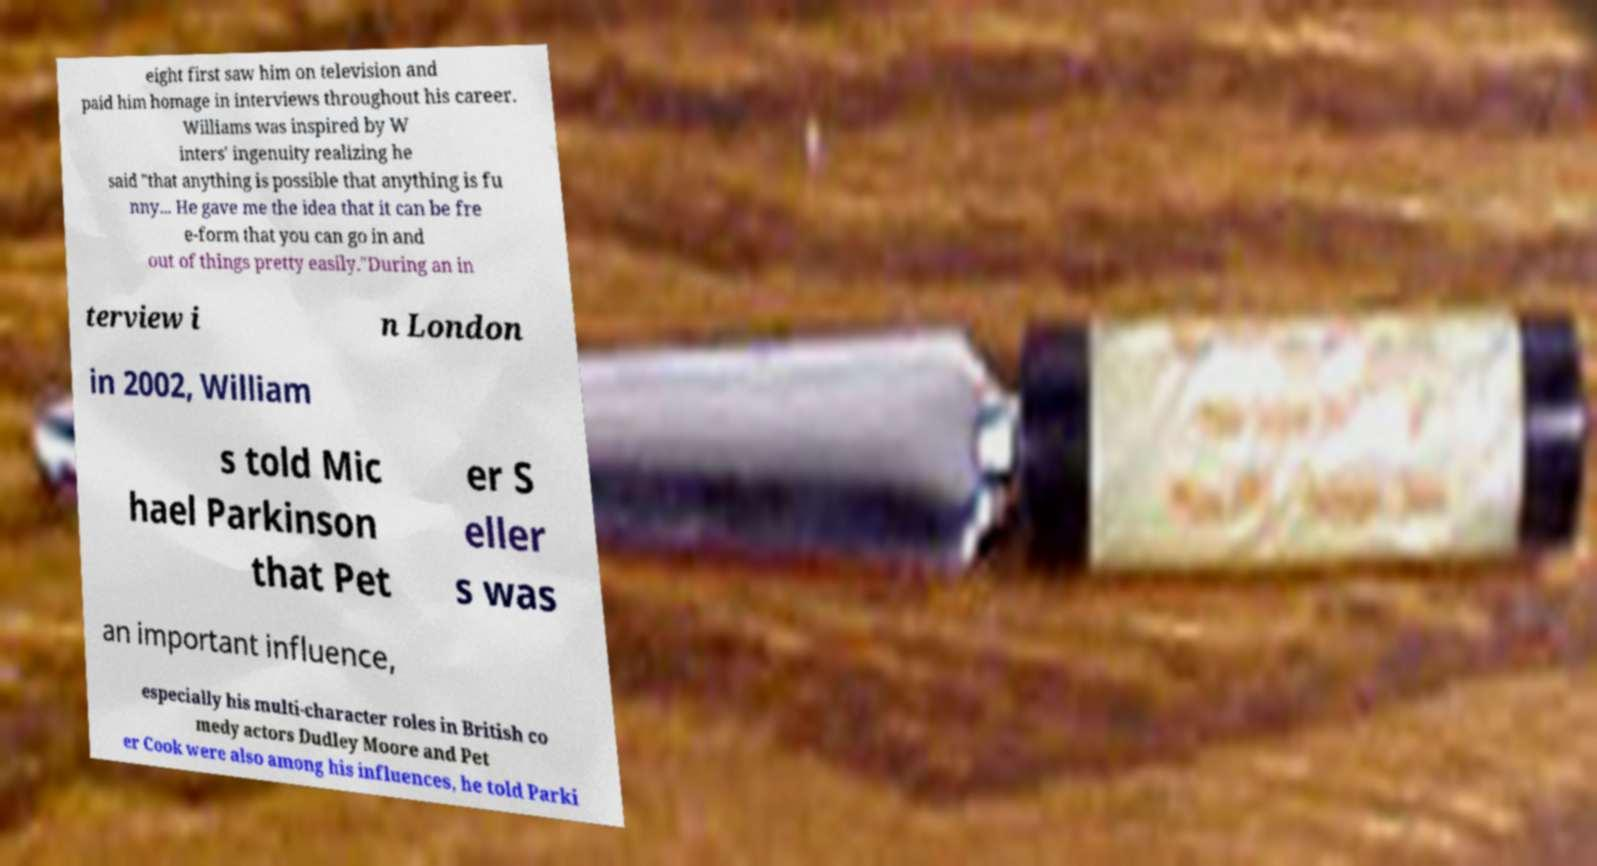Could you assist in decoding the text presented in this image and type it out clearly? eight first saw him on television and paid him homage in interviews throughout his career. Williams was inspired by W inters' ingenuity realizing he said "that anything is possible that anything is fu nny... He gave me the idea that it can be fre e-form that you can go in and out of things pretty easily."During an in terview i n London in 2002, William s told Mic hael Parkinson that Pet er S eller s was an important influence, especially his multi-character roles in British co medy actors Dudley Moore and Pet er Cook were also among his influences, he told Parki 